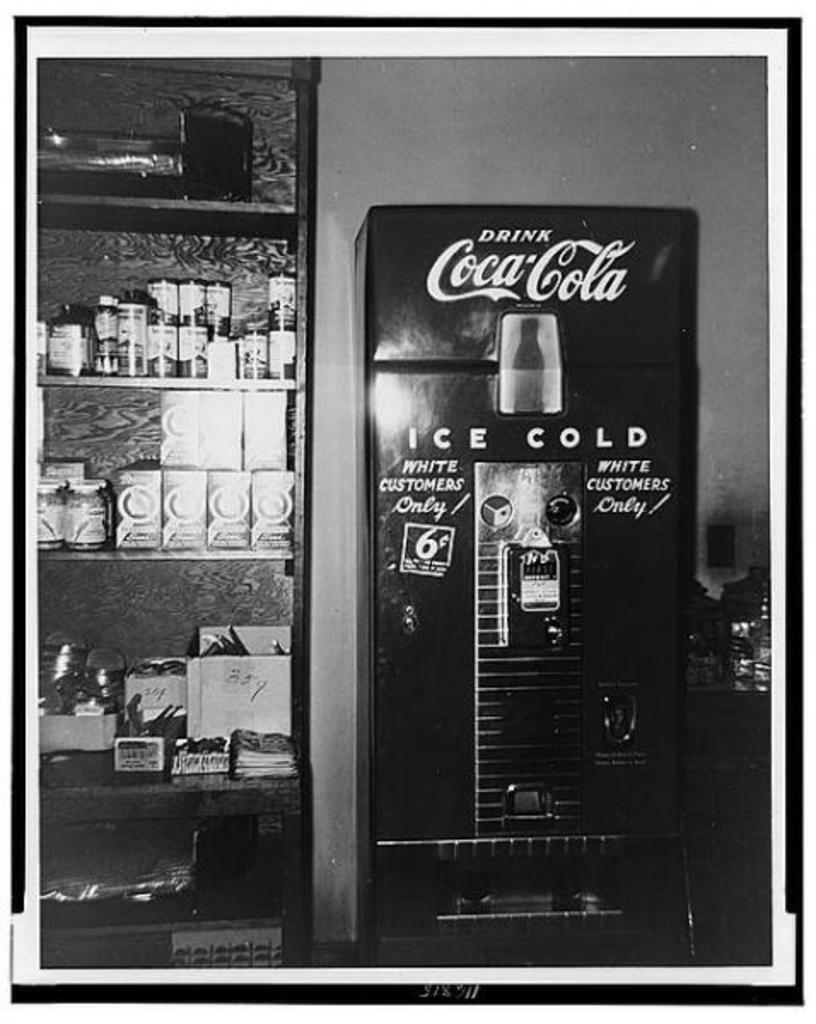What is the color scheme of the image? The image is black and white. What can be seen in the image? There is a soft drink machine in the image. What else is present in the image besides the soft drink machine? Objects are placed in a rack in the image. What type of advertisement can be seen on the sock in the image? There is no sock present in the image, and therefore no advertisement can be seen on it. 